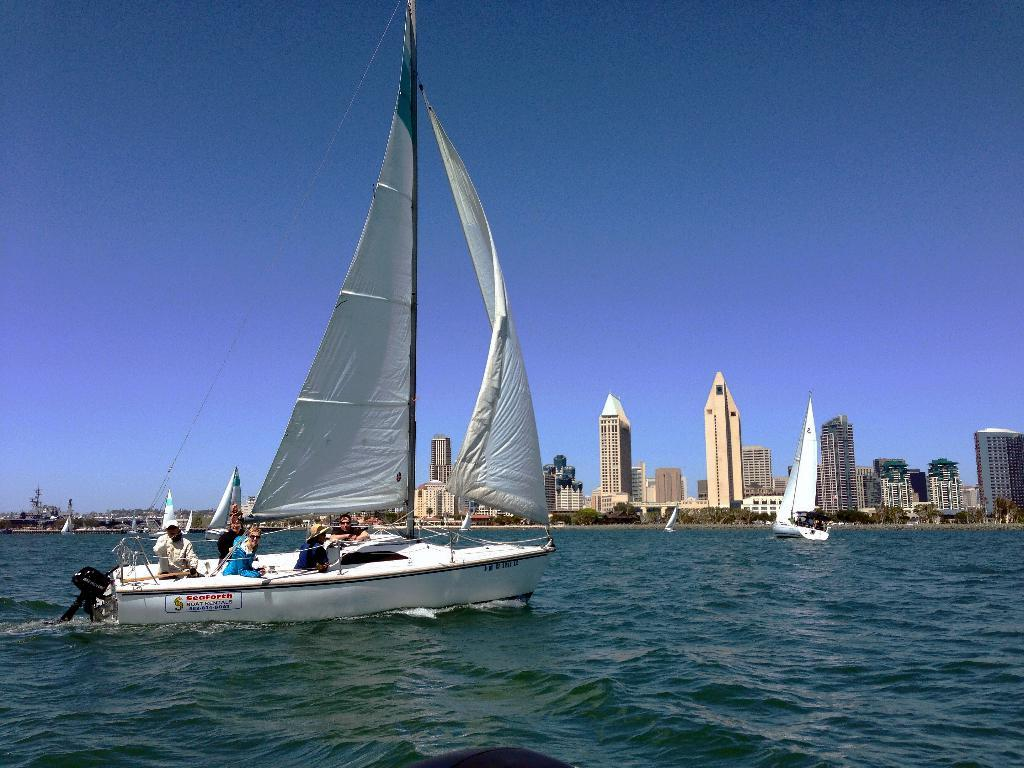What is the main subject of the image? The main subject of the image is boats on a water body. Are there any people present in the image? Yes, there are people on at least one of the boats. What can be seen in the background of the image? There are buildings and trees in the background of the image. How would you describe the weather in the image? The sky is clear in the image, suggesting good weather. Can you see any fangs on the people in the image? There are no fangs visible on the people in the image, as fangs are not a natural human feature. 